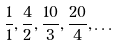Convert formula to latex. <formula><loc_0><loc_0><loc_500><loc_500>\frac { 1 } { 1 } , \frac { 4 } { 2 } , \frac { 1 0 } { 3 } , \frac { 2 0 } { 4 } , \dots</formula> 